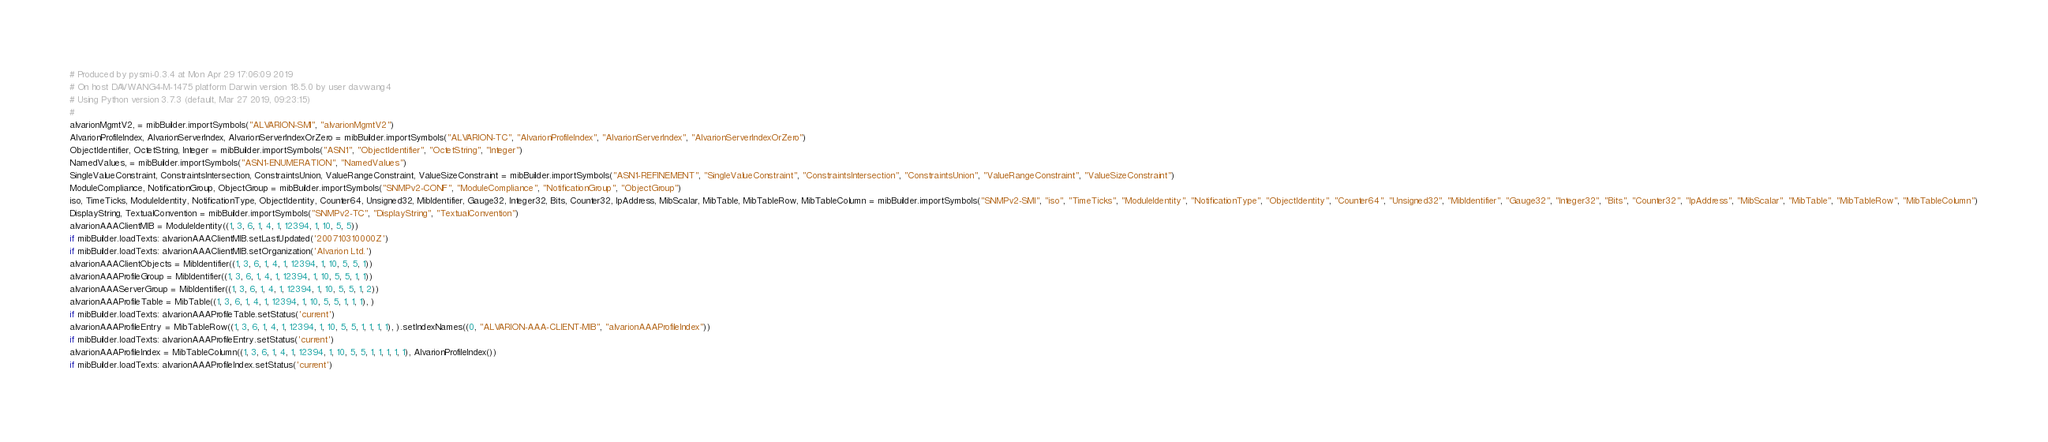Convert code to text. <code><loc_0><loc_0><loc_500><loc_500><_Python_># Produced by pysmi-0.3.4 at Mon Apr 29 17:06:09 2019
# On host DAVWANG4-M-1475 platform Darwin version 18.5.0 by user davwang4
# Using Python version 3.7.3 (default, Mar 27 2019, 09:23:15) 
#
alvarionMgmtV2, = mibBuilder.importSymbols("ALVARION-SMI", "alvarionMgmtV2")
AlvarionProfileIndex, AlvarionServerIndex, AlvarionServerIndexOrZero = mibBuilder.importSymbols("ALVARION-TC", "AlvarionProfileIndex", "AlvarionServerIndex", "AlvarionServerIndexOrZero")
ObjectIdentifier, OctetString, Integer = mibBuilder.importSymbols("ASN1", "ObjectIdentifier", "OctetString", "Integer")
NamedValues, = mibBuilder.importSymbols("ASN1-ENUMERATION", "NamedValues")
SingleValueConstraint, ConstraintsIntersection, ConstraintsUnion, ValueRangeConstraint, ValueSizeConstraint = mibBuilder.importSymbols("ASN1-REFINEMENT", "SingleValueConstraint", "ConstraintsIntersection", "ConstraintsUnion", "ValueRangeConstraint", "ValueSizeConstraint")
ModuleCompliance, NotificationGroup, ObjectGroup = mibBuilder.importSymbols("SNMPv2-CONF", "ModuleCompliance", "NotificationGroup", "ObjectGroup")
iso, TimeTicks, ModuleIdentity, NotificationType, ObjectIdentity, Counter64, Unsigned32, MibIdentifier, Gauge32, Integer32, Bits, Counter32, IpAddress, MibScalar, MibTable, MibTableRow, MibTableColumn = mibBuilder.importSymbols("SNMPv2-SMI", "iso", "TimeTicks", "ModuleIdentity", "NotificationType", "ObjectIdentity", "Counter64", "Unsigned32", "MibIdentifier", "Gauge32", "Integer32", "Bits", "Counter32", "IpAddress", "MibScalar", "MibTable", "MibTableRow", "MibTableColumn")
DisplayString, TextualConvention = mibBuilder.importSymbols("SNMPv2-TC", "DisplayString", "TextualConvention")
alvarionAAAClientMIB = ModuleIdentity((1, 3, 6, 1, 4, 1, 12394, 1, 10, 5, 5))
if mibBuilder.loadTexts: alvarionAAAClientMIB.setLastUpdated('200710310000Z')
if mibBuilder.loadTexts: alvarionAAAClientMIB.setOrganization('Alvarion Ltd.')
alvarionAAAClientObjects = MibIdentifier((1, 3, 6, 1, 4, 1, 12394, 1, 10, 5, 5, 1))
alvarionAAAProfileGroup = MibIdentifier((1, 3, 6, 1, 4, 1, 12394, 1, 10, 5, 5, 1, 1))
alvarionAAAServerGroup = MibIdentifier((1, 3, 6, 1, 4, 1, 12394, 1, 10, 5, 5, 1, 2))
alvarionAAAProfileTable = MibTable((1, 3, 6, 1, 4, 1, 12394, 1, 10, 5, 5, 1, 1, 1), )
if mibBuilder.loadTexts: alvarionAAAProfileTable.setStatus('current')
alvarionAAAProfileEntry = MibTableRow((1, 3, 6, 1, 4, 1, 12394, 1, 10, 5, 5, 1, 1, 1, 1), ).setIndexNames((0, "ALVARION-AAA-CLIENT-MIB", "alvarionAAAProfileIndex"))
if mibBuilder.loadTexts: alvarionAAAProfileEntry.setStatus('current')
alvarionAAAProfileIndex = MibTableColumn((1, 3, 6, 1, 4, 1, 12394, 1, 10, 5, 5, 1, 1, 1, 1, 1), AlvarionProfileIndex())
if mibBuilder.loadTexts: alvarionAAAProfileIndex.setStatus('current')</code> 